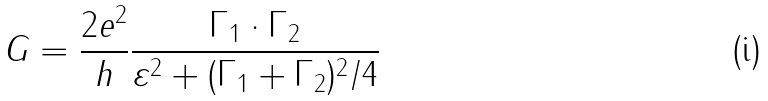<formula> <loc_0><loc_0><loc_500><loc_500>G = \frac { 2 e ^ { 2 } } { h } \frac { \Gamma _ { 1 } \cdot \Gamma _ { 2 } } { \varepsilon ^ { 2 } + ( \Gamma _ { 1 } + \Gamma _ { 2 } ) ^ { 2 } / 4 }</formula> 